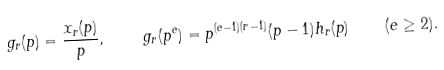Convert formula to latex. <formula><loc_0><loc_0><loc_500><loc_500>g _ { r } ( p ) = \frac { x _ { r } ( p ) } { p } , \quad g _ { r } ( p ^ { e } ) = p ^ { ( e - 1 ) ( r - 1 ) } ( p - 1 ) h _ { r } ( p ) \quad ( e \geq 2 ) .</formula> 